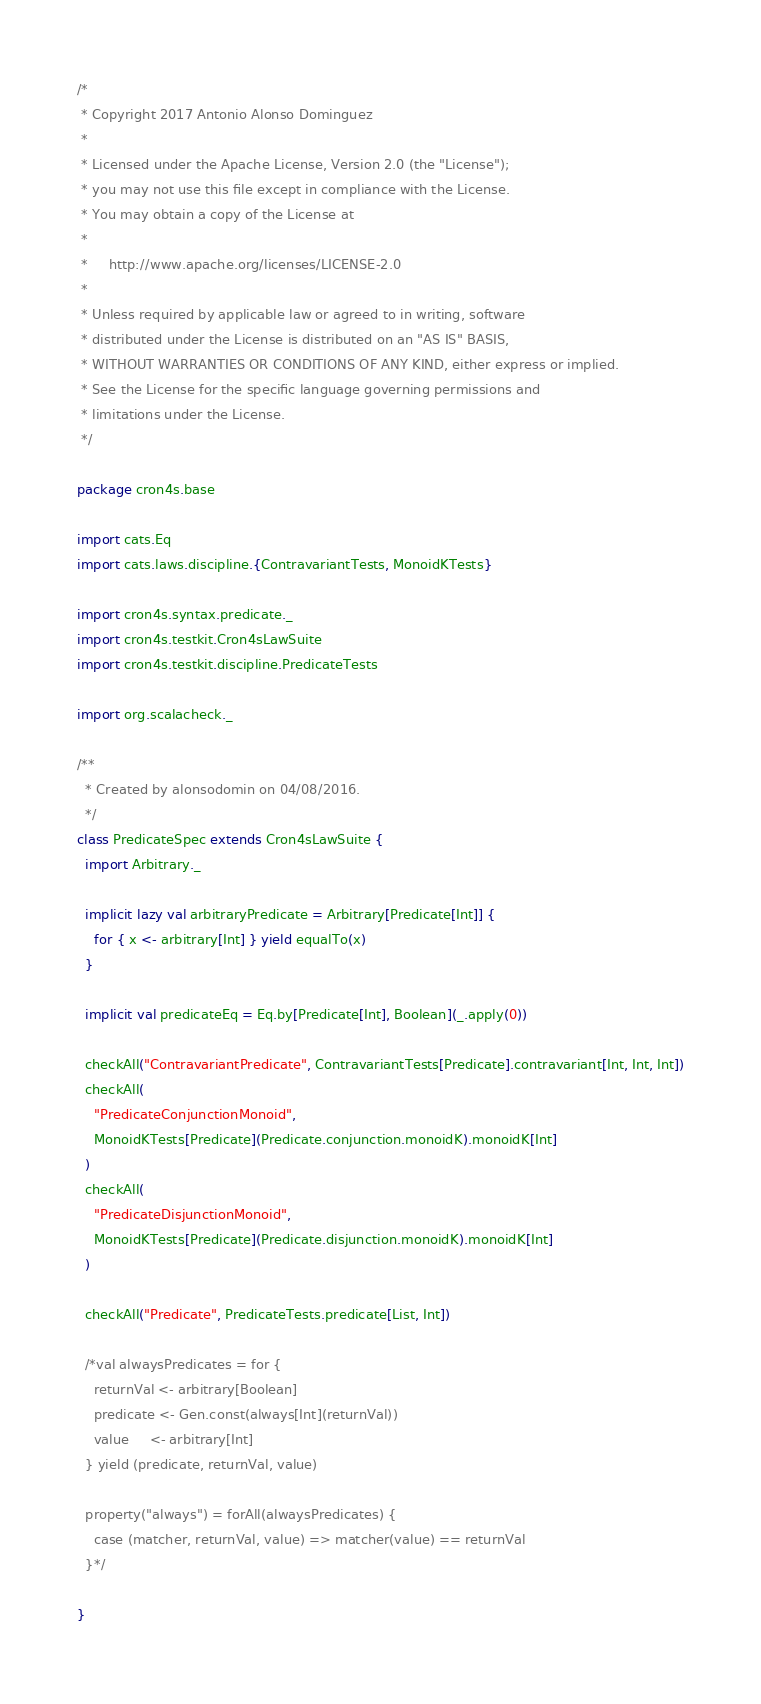<code> <loc_0><loc_0><loc_500><loc_500><_Scala_>/*
 * Copyright 2017 Antonio Alonso Dominguez
 *
 * Licensed under the Apache License, Version 2.0 (the "License");
 * you may not use this file except in compliance with the License.
 * You may obtain a copy of the License at
 *
 *     http://www.apache.org/licenses/LICENSE-2.0
 *
 * Unless required by applicable law or agreed to in writing, software
 * distributed under the License is distributed on an "AS IS" BASIS,
 * WITHOUT WARRANTIES OR CONDITIONS OF ANY KIND, either express or implied.
 * See the License for the specific language governing permissions and
 * limitations under the License.
 */

package cron4s.base

import cats.Eq
import cats.laws.discipline.{ContravariantTests, MonoidKTests}

import cron4s.syntax.predicate._
import cron4s.testkit.Cron4sLawSuite
import cron4s.testkit.discipline.PredicateTests

import org.scalacheck._

/**
  * Created by alonsodomin on 04/08/2016.
  */
class PredicateSpec extends Cron4sLawSuite {
  import Arbitrary._

  implicit lazy val arbitraryPredicate = Arbitrary[Predicate[Int]] {
    for { x <- arbitrary[Int] } yield equalTo(x)
  }

  implicit val predicateEq = Eq.by[Predicate[Int], Boolean](_.apply(0))

  checkAll("ContravariantPredicate", ContravariantTests[Predicate].contravariant[Int, Int, Int])
  checkAll(
    "PredicateConjunctionMonoid",
    MonoidKTests[Predicate](Predicate.conjunction.monoidK).monoidK[Int]
  )
  checkAll(
    "PredicateDisjunctionMonoid",
    MonoidKTests[Predicate](Predicate.disjunction.monoidK).monoidK[Int]
  )

  checkAll("Predicate", PredicateTests.predicate[List, Int])

  /*val alwaysPredicates = for {
    returnVal <- arbitrary[Boolean]
    predicate <- Gen.const(always[Int](returnVal))
    value     <- arbitrary[Int]
  } yield (predicate, returnVal, value)

  property("always") = forAll(alwaysPredicates) {
    case (matcher, returnVal, value) => matcher(value) == returnVal
  }*/

}
</code> 